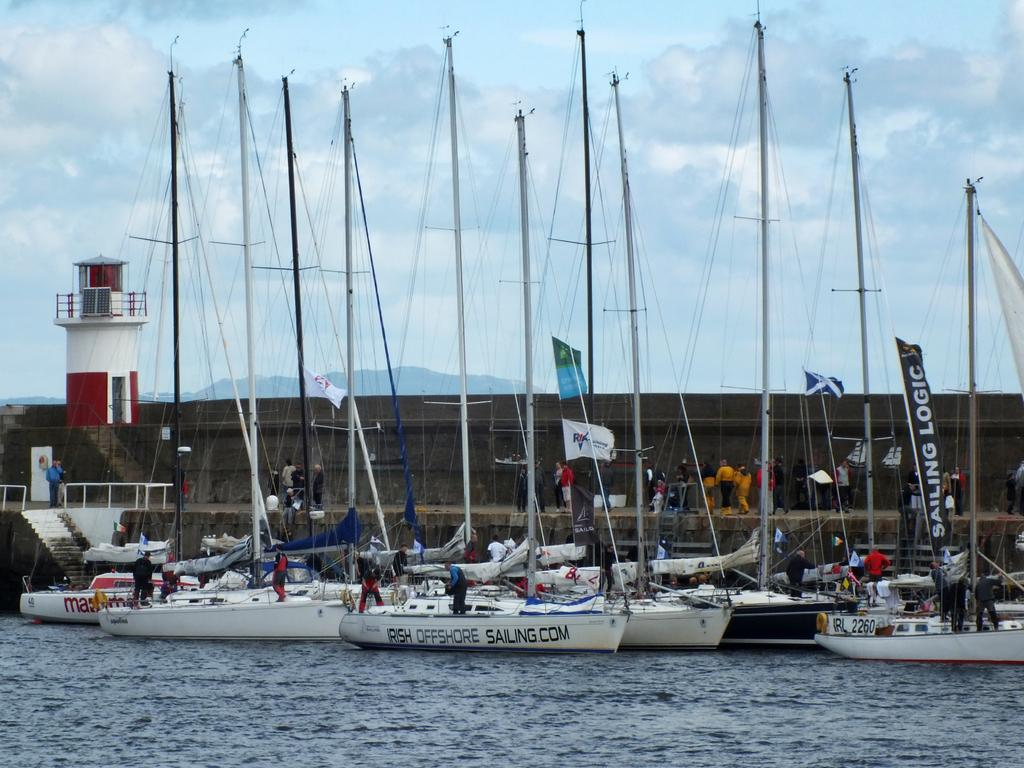<image>
Describe the image concisely. a boat with Irish Offshore sailing written on the side 